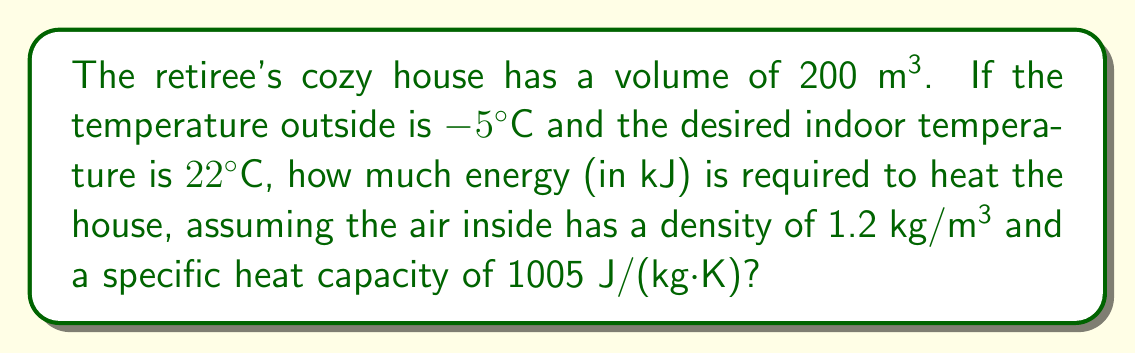Teach me how to tackle this problem. To solve this problem, we'll follow these steps:

1) First, we need to calculate the mass of air in the house:
   $m = \rho V$
   Where $\rho$ is the density and $V$ is the volume.
   $m = 1.2 \text{ kg/m³} \times 200 \text{ m³} = 240 \text{ kg}$

2) Next, we'll use the formula for heat energy:
   $Q = mc\Delta T$
   Where $m$ is the mass, $c$ is the specific heat capacity, and $\Delta T$ is the change in temperature.

3) Calculate the temperature change:
   $\Delta T = T_{\text{final}} - T_{\text{initial}} = 22°C - (-5°C) = 27°C = 27 \text{ K}$

4) Now we can plug everything into our heat energy formula:
   $Q = 240 \text{ kg} \times 1005 \text{ J/(kg·K)} \times 27 \text{ K}$

5) Calculate:
   $Q = 6,512,400 \text{ J} = 6512.4 \text{ kJ}$

Therefore, the energy required to heat the house is approximately 6512.4 kJ.
Answer: 6512.4 kJ 